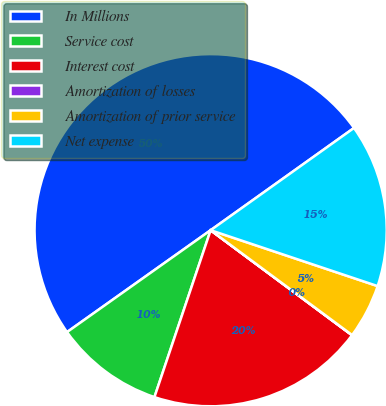Convert chart. <chart><loc_0><loc_0><loc_500><loc_500><pie_chart><fcel>In Millions<fcel>Service cost<fcel>Interest cost<fcel>Amortization of losses<fcel>Amortization of prior service<fcel>Net expense<nl><fcel>49.96%<fcel>10.01%<fcel>20.0%<fcel>0.02%<fcel>5.01%<fcel>15.0%<nl></chart> 